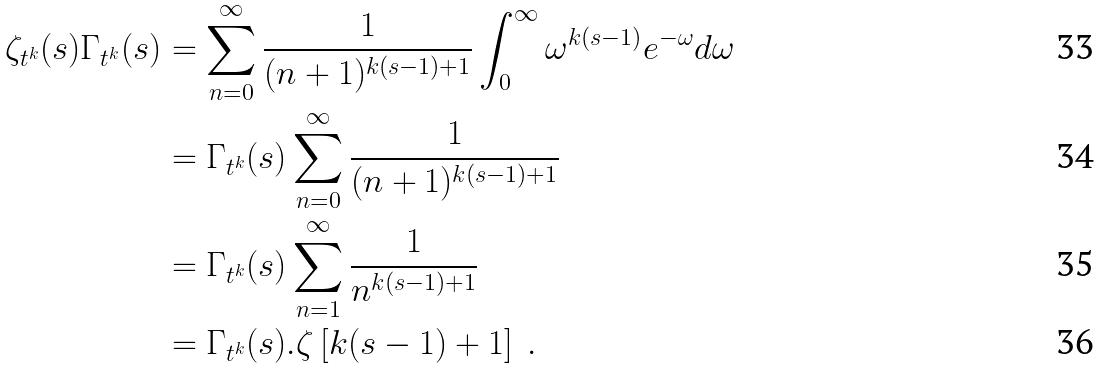Convert formula to latex. <formula><loc_0><loc_0><loc_500><loc_500>\zeta _ { t ^ { k } } ( s ) \Gamma _ { t ^ { k } } ( s ) & = \sum _ { n = 0 } ^ { \infty } \frac { 1 } { ( n + 1 ) ^ { k ( s - 1 ) + 1 } } \int _ { 0 } ^ { \infty } \omega ^ { k ( s - 1 ) } e ^ { - \omega } d \omega \\ & = \Gamma _ { t ^ { k } } ( s ) \sum _ { n = 0 } ^ { \infty } \frac { 1 } { ( n + 1 ) ^ { k ( s - 1 ) + 1 } } \\ & = \Gamma _ { t ^ { k } } ( s ) \sum _ { n = 1 } ^ { \infty } \frac { 1 } { n ^ { k ( s - 1 ) + 1 } } \\ & = \Gamma _ { t ^ { k } } ( s ) . \zeta \left [ k ( s - 1 ) + 1 \right ] \ .</formula> 